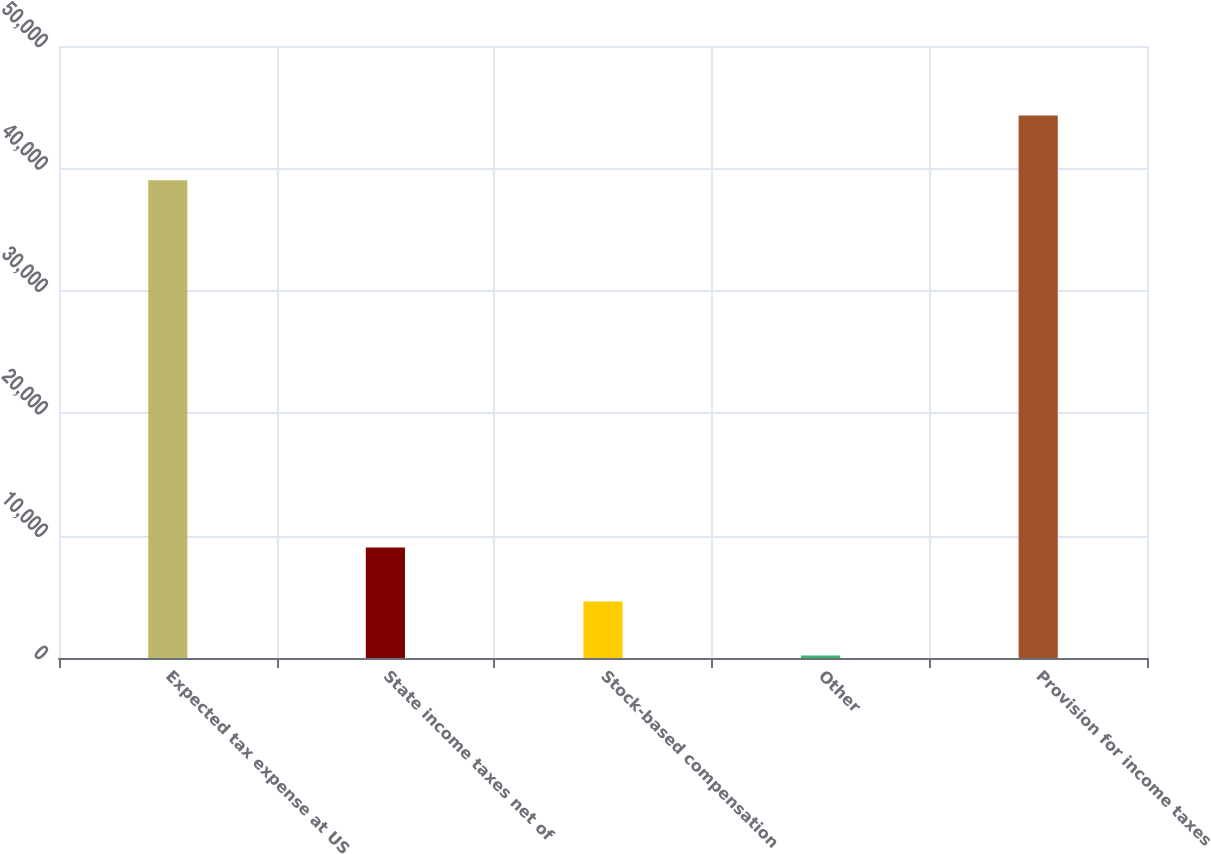Convert chart to OTSL. <chart><loc_0><loc_0><loc_500><loc_500><bar_chart><fcel>Expected tax expense at US<fcel>State income taxes net of<fcel>Stock-based compensation<fcel>Other<fcel>Provision for income taxes<nl><fcel>39025<fcel>9021.8<fcel>4609.9<fcel>198<fcel>44317<nl></chart> 